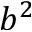<formula> <loc_0><loc_0><loc_500><loc_500>b ^ { 2 }</formula> 